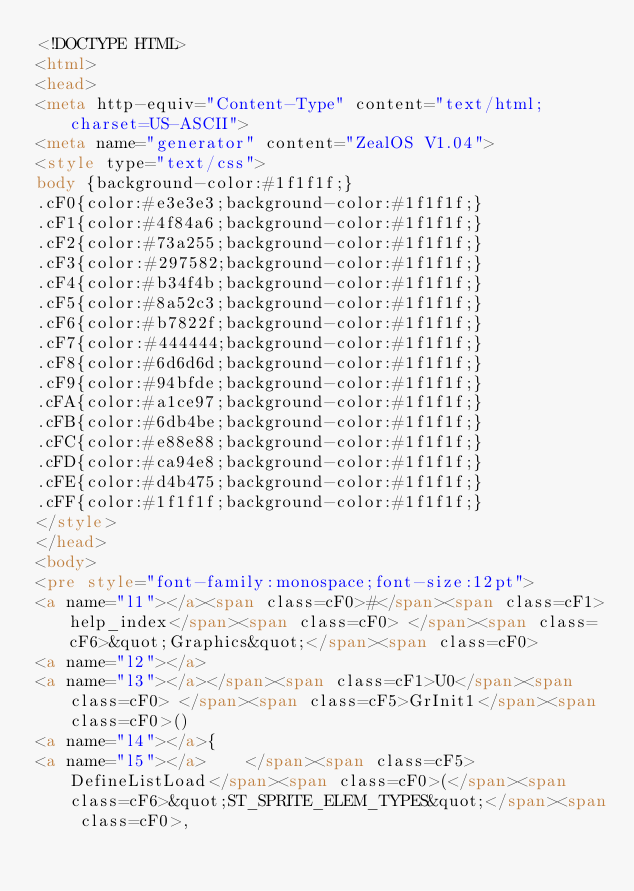<code> <loc_0><loc_0><loc_500><loc_500><_HTML_><!DOCTYPE HTML>
<html>
<head>
<meta http-equiv="Content-Type" content="text/html;charset=US-ASCII">
<meta name="generator" content="ZealOS V1.04">
<style type="text/css">
body {background-color:#1f1f1f;}
.cF0{color:#e3e3e3;background-color:#1f1f1f;}
.cF1{color:#4f84a6;background-color:#1f1f1f;}
.cF2{color:#73a255;background-color:#1f1f1f;}
.cF3{color:#297582;background-color:#1f1f1f;}
.cF4{color:#b34f4b;background-color:#1f1f1f;}
.cF5{color:#8a52c3;background-color:#1f1f1f;}
.cF6{color:#b7822f;background-color:#1f1f1f;}
.cF7{color:#444444;background-color:#1f1f1f;}
.cF8{color:#6d6d6d;background-color:#1f1f1f;}
.cF9{color:#94bfde;background-color:#1f1f1f;}
.cFA{color:#a1ce97;background-color:#1f1f1f;}
.cFB{color:#6db4be;background-color:#1f1f1f;}
.cFC{color:#e88e88;background-color:#1f1f1f;}
.cFD{color:#ca94e8;background-color:#1f1f1f;}
.cFE{color:#d4b475;background-color:#1f1f1f;}
.cFF{color:#1f1f1f;background-color:#1f1f1f;}
</style>
</head>
<body>
<pre style="font-family:monospace;font-size:12pt">
<a name="l1"></a><span class=cF0>#</span><span class=cF1>help_index</span><span class=cF0> </span><span class=cF6>&quot;Graphics&quot;</span><span class=cF0>
<a name="l2"></a>
<a name="l3"></a></span><span class=cF1>U0</span><span class=cF0> </span><span class=cF5>GrInit1</span><span class=cF0>()
<a name="l4"></a>{
<a name="l5"></a>    </span><span class=cF5>DefineListLoad</span><span class=cF0>(</span><span class=cF6>&quot;ST_SPRITE_ELEM_TYPES&quot;</span><span class=cF0>,</code> 